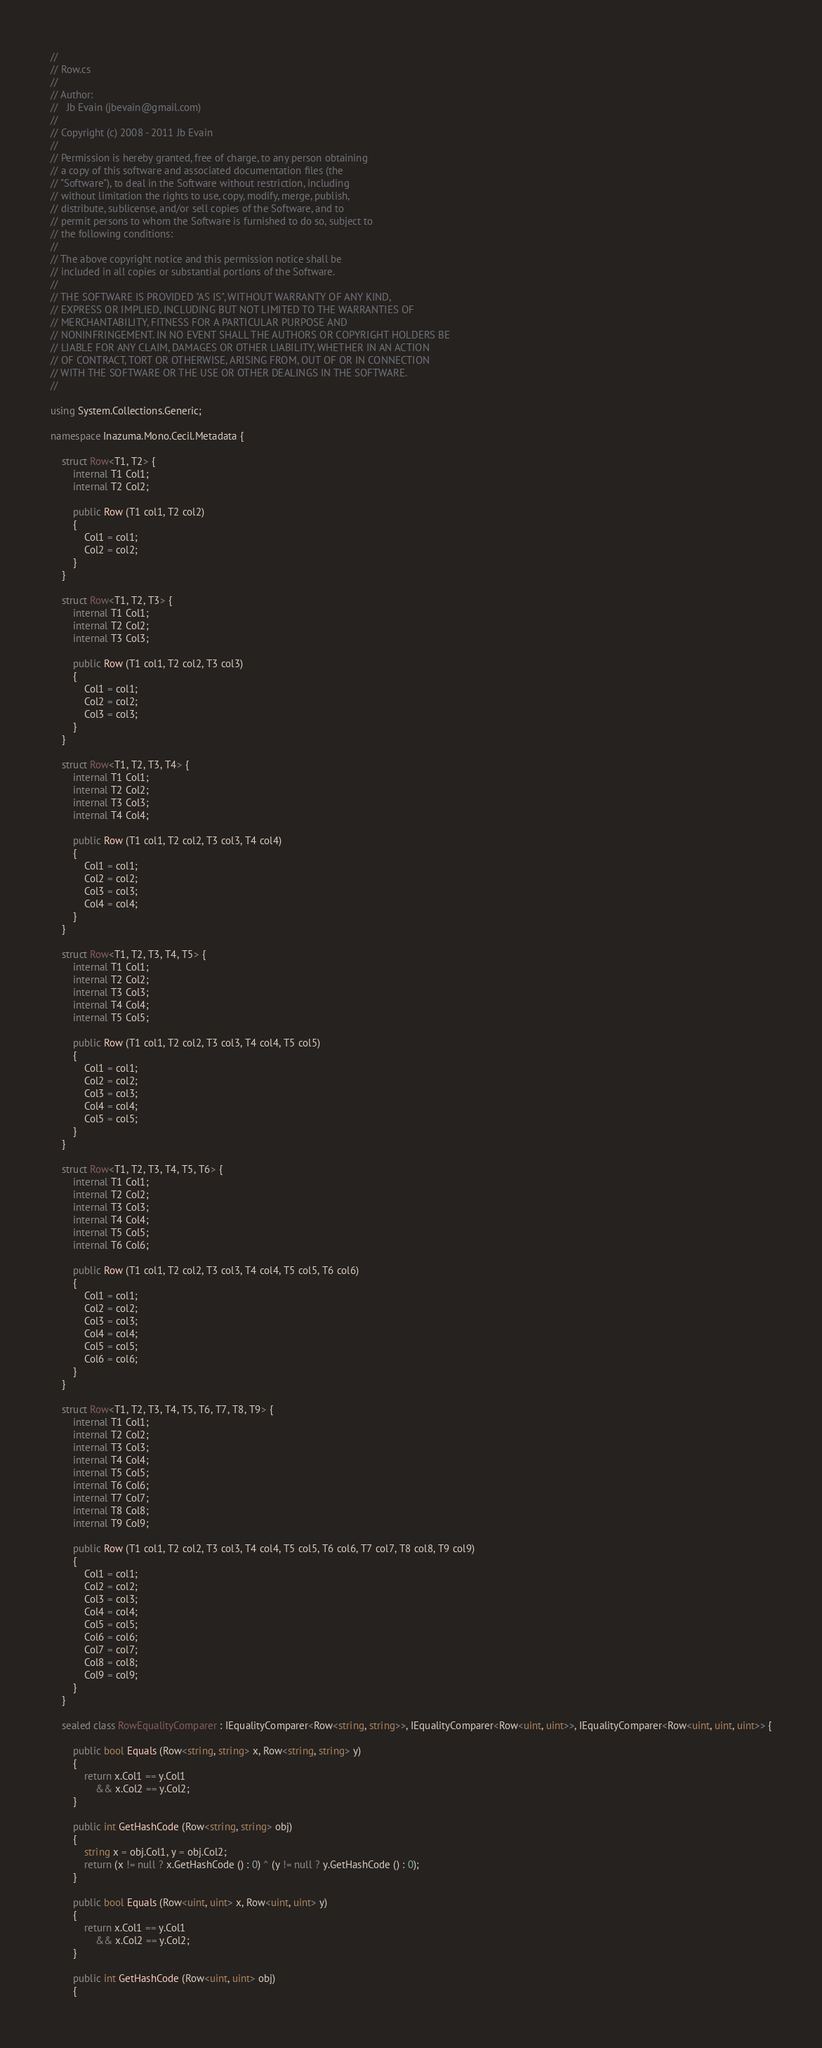<code> <loc_0><loc_0><loc_500><loc_500><_C#_>//
// Row.cs
//
// Author:
//   Jb Evain (jbevain@gmail.com)
//
// Copyright (c) 2008 - 2011 Jb Evain
//
// Permission is hereby granted, free of charge, to any person obtaining
// a copy of this software and associated documentation files (the
// "Software"), to deal in the Software without restriction, including
// without limitation the rights to use, copy, modify, merge, publish,
// distribute, sublicense, and/or sell copies of the Software, and to
// permit persons to whom the Software is furnished to do so, subject to
// the following conditions:
//
// The above copyright notice and this permission notice shall be
// included in all copies or substantial portions of the Software.
//
// THE SOFTWARE IS PROVIDED "AS IS", WITHOUT WARRANTY OF ANY KIND,
// EXPRESS OR IMPLIED, INCLUDING BUT NOT LIMITED TO THE WARRANTIES OF
// MERCHANTABILITY, FITNESS FOR A PARTICULAR PURPOSE AND
// NONINFRINGEMENT. IN NO EVENT SHALL THE AUTHORS OR COPYRIGHT HOLDERS BE
// LIABLE FOR ANY CLAIM, DAMAGES OR OTHER LIABILITY, WHETHER IN AN ACTION
// OF CONTRACT, TORT OR OTHERWISE, ARISING FROM, OUT OF OR IN CONNECTION
// WITH THE SOFTWARE OR THE USE OR OTHER DEALINGS IN THE SOFTWARE.
//

using System.Collections.Generic;

namespace Inazuma.Mono.Cecil.Metadata {

	struct Row<T1, T2> {
		internal T1 Col1;
		internal T2 Col2;

		public Row (T1 col1, T2 col2)
		{
			Col1 = col1;
			Col2 = col2;
		}
	}

	struct Row<T1, T2, T3> {
		internal T1 Col1;
		internal T2 Col2;
		internal T3 Col3;

		public Row (T1 col1, T2 col2, T3 col3)
		{
			Col1 = col1;
			Col2 = col2;
			Col3 = col3;
		}
	}

	struct Row<T1, T2, T3, T4> {
		internal T1 Col1;
		internal T2 Col2;
		internal T3 Col3;
		internal T4 Col4;

		public Row (T1 col1, T2 col2, T3 col3, T4 col4)
		{
			Col1 = col1;
			Col2 = col2;
			Col3 = col3;
			Col4 = col4;
		}
	}

	struct Row<T1, T2, T3, T4, T5> {
		internal T1 Col1;
		internal T2 Col2;
		internal T3 Col3;
		internal T4 Col4;
		internal T5 Col5;

		public Row (T1 col1, T2 col2, T3 col3, T4 col4, T5 col5)
		{
			Col1 = col1;
			Col2 = col2;
			Col3 = col3;
			Col4 = col4;
			Col5 = col5;
		}
	}

	struct Row<T1, T2, T3, T4, T5, T6> {
		internal T1 Col1;
		internal T2 Col2;
		internal T3 Col3;
		internal T4 Col4;
		internal T5 Col5;
		internal T6 Col6;

		public Row (T1 col1, T2 col2, T3 col3, T4 col4, T5 col5, T6 col6)
		{
			Col1 = col1;
			Col2 = col2;
			Col3 = col3;
			Col4 = col4;
			Col5 = col5;
			Col6 = col6;
		}
	}

	struct Row<T1, T2, T3, T4, T5, T6, T7, T8, T9> {
		internal T1 Col1;
		internal T2 Col2;
		internal T3 Col3;
		internal T4 Col4;
		internal T5 Col5;
		internal T6 Col6;
		internal T7 Col7;
		internal T8 Col8;
		internal T9 Col9;

		public Row (T1 col1, T2 col2, T3 col3, T4 col4, T5 col5, T6 col6, T7 col7, T8 col8, T9 col9)
		{
			Col1 = col1;
			Col2 = col2;
			Col3 = col3;
			Col4 = col4;
			Col5 = col5;
			Col6 = col6;
			Col7 = col7;
			Col8 = col8;
			Col9 = col9;
		}
	}

	sealed class RowEqualityComparer : IEqualityComparer<Row<string, string>>, IEqualityComparer<Row<uint, uint>>, IEqualityComparer<Row<uint, uint, uint>> {

		public bool Equals (Row<string, string> x, Row<string, string> y)
		{
			return x.Col1 == y.Col1
				&& x.Col2 == y.Col2;
		}

		public int GetHashCode (Row<string, string> obj)
		{
			string x = obj.Col1, y = obj.Col2;
			return (x != null ? x.GetHashCode () : 0) ^ (y != null ? y.GetHashCode () : 0);
		}

		public bool Equals (Row<uint, uint> x, Row<uint, uint> y)
		{
			return x.Col1 == y.Col1
				&& x.Col2 == y.Col2;
		}

		public int GetHashCode (Row<uint, uint> obj)
		{</code> 